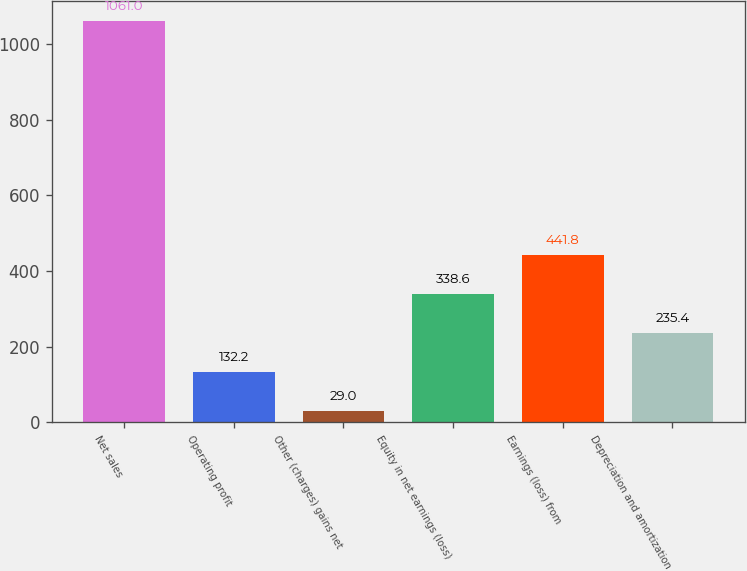Convert chart to OTSL. <chart><loc_0><loc_0><loc_500><loc_500><bar_chart><fcel>Net sales<fcel>Operating profit<fcel>Other (charges) gains net<fcel>Equity in net earnings (loss)<fcel>Earnings (loss) from<fcel>Depreciation and amortization<nl><fcel>1061<fcel>132.2<fcel>29<fcel>338.6<fcel>441.8<fcel>235.4<nl></chart> 